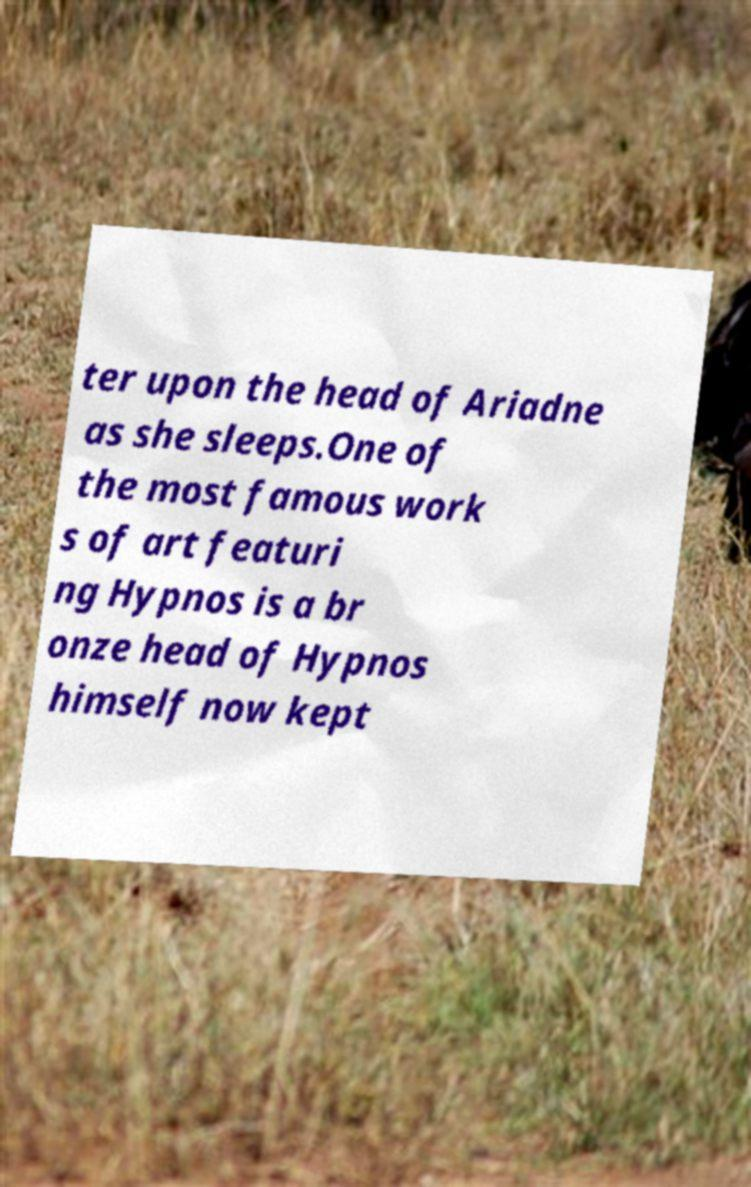Could you extract and type out the text from this image? ter upon the head of Ariadne as she sleeps.One of the most famous work s of art featuri ng Hypnos is a br onze head of Hypnos himself now kept 